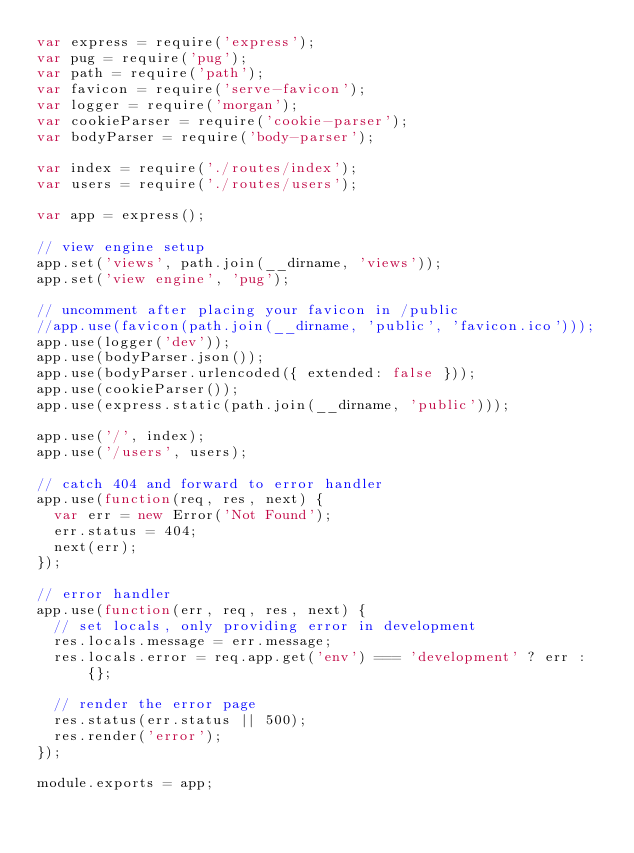<code> <loc_0><loc_0><loc_500><loc_500><_JavaScript_>var express = require('express');
var pug = require('pug');
var path = require('path');
var favicon = require('serve-favicon');
var logger = require('morgan');
var cookieParser = require('cookie-parser');
var bodyParser = require('body-parser');

var index = require('./routes/index');
var users = require('./routes/users');

var app = express();

// view engine setup
app.set('views', path.join(__dirname, 'views'));
app.set('view engine', 'pug');

// uncomment after placing your favicon in /public
//app.use(favicon(path.join(__dirname, 'public', 'favicon.ico')));
app.use(logger('dev'));
app.use(bodyParser.json());
app.use(bodyParser.urlencoded({ extended: false }));
app.use(cookieParser());
app.use(express.static(path.join(__dirname, 'public')));

app.use('/', index);
app.use('/users', users);

// catch 404 and forward to error handler
app.use(function(req, res, next) {
  var err = new Error('Not Found');
  err.status = 404;
  next(err);
});

// error handler
app.use(function(err, req, res, next) {
  // set locals, only providing error in development
  res.locals.message = err.message;
  res.locals.error = req.app.get('env') === 'development' ? err : {};

  // render the error page
  res.status(err.status || 500);
  res.render('error');
});

module.exports = app;
</code> 